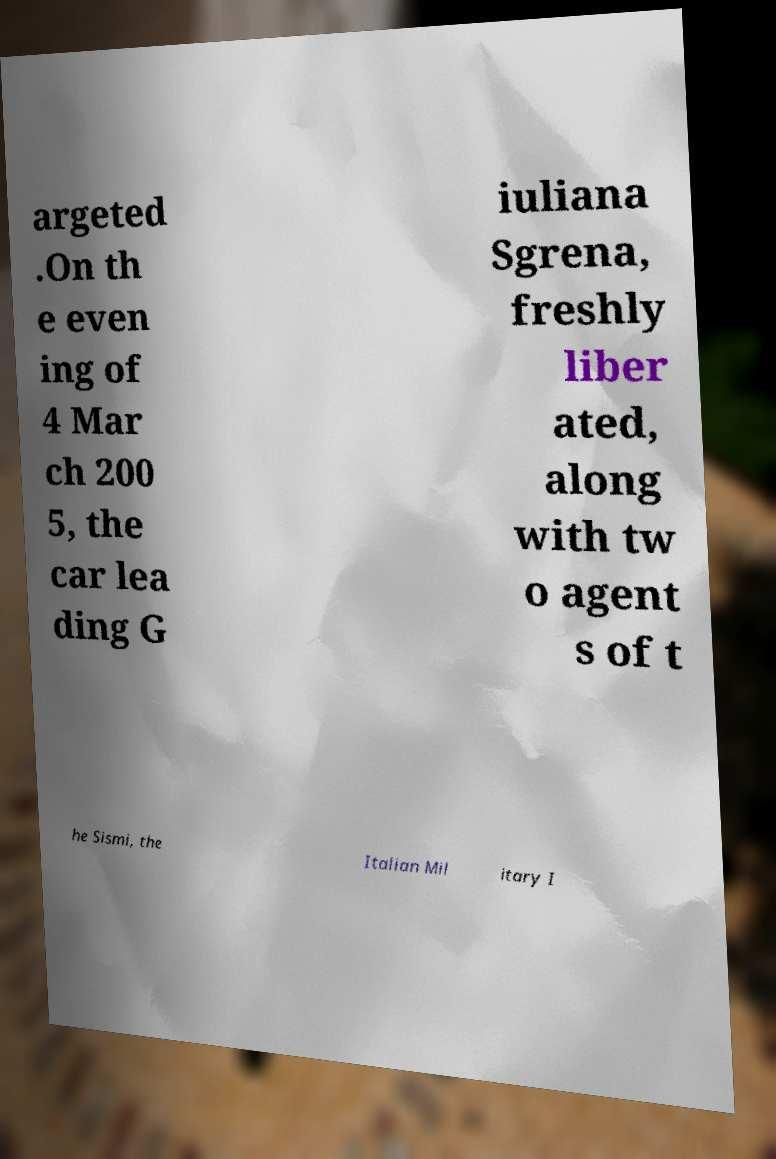Can you accurately transcribe the text from the provided image for me? argeted .On th e even ing of 4 Mar ch 200 5, the car lea ding G iuliana Sgrena, freshly liber ated, along with tw o agent s of t he Sismi, the Italian Mil itary I 